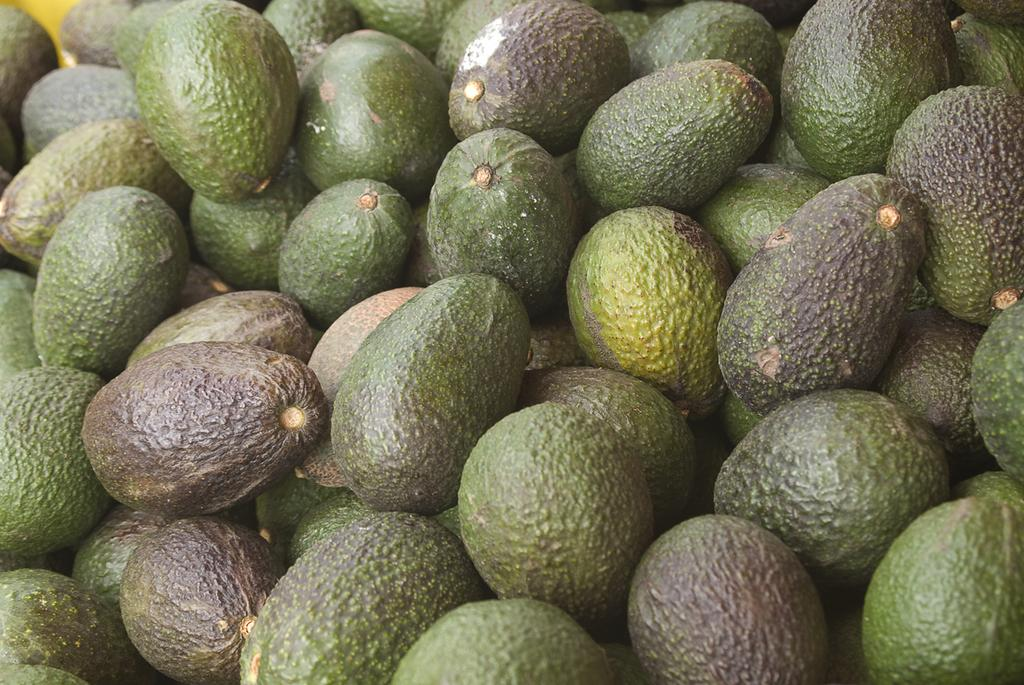What type of fruits are present in the image? There are many green Avogadro fruits in the image. What type of teeth can be seen in the image? There are no teeth present in the image; it features green Avogadro fruits. What type of wilderness can be seen in the image? There is no wilderness present in the image; it features green Avogadro fruits. 